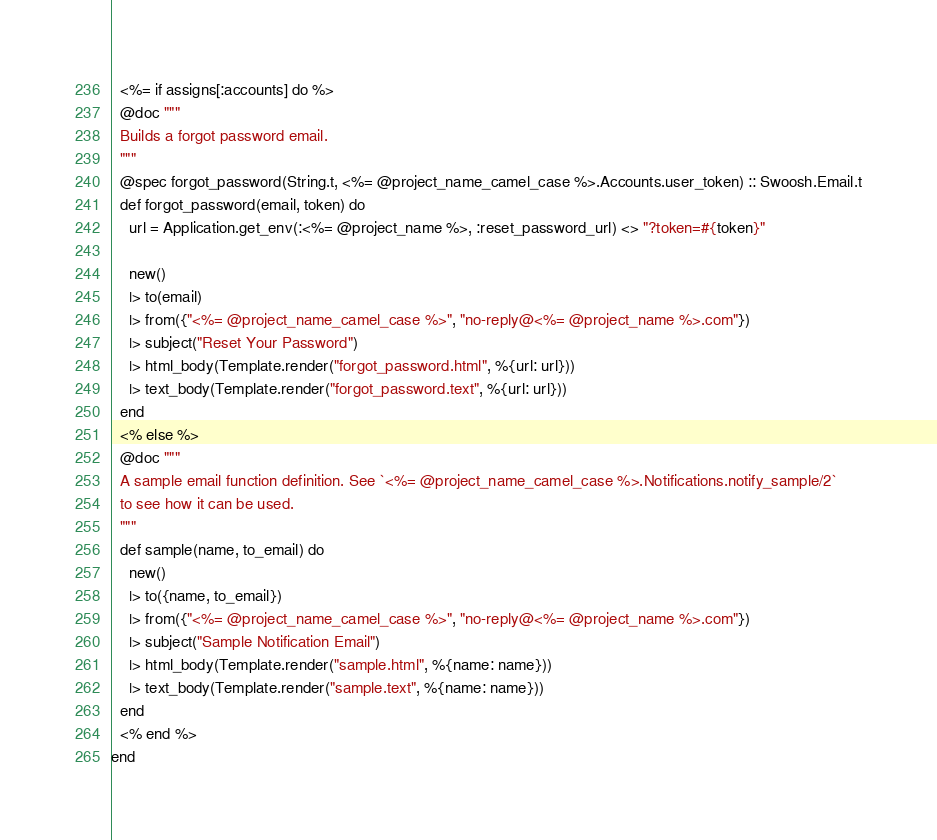Convert code to text. <code><loc_0><loc_0><loc_500><loc_500><_Elixir_>  <%= if assigns[:accounts] do %>
  @doc """
  Builds a forgot password email.
  """
  @spec forgot_password(String.t, <%= @project_name_camel_case %>.Accounts.user_token) :: Swoosh.Email.t
  def forgot_password(email, token) do
    url = Application.get_env(:<%= @project_name %>, :reset_password_url) <> "?token=#{token}"

    new()
    |> to(email)
    |> from({"<%= @project_name_camel_case %>", "no-reply@<%= @project_name %>.com"})
    |> subject("Reset Your Password")
    |> html_body(Template.render("forgot_password.html", %{url: url}))
    |> text_body(Template.render("forgot_password.text", %{url: url}))
  end
  <% else %>
  @doc """
  A sample email function definition. See `<%= @project_name_camel_case %>.Notifications.notify_sample/2`
  to see how it can be used.
  """
  def sample(name, to_email) do
    new()
    |> to({name, to_email})
    |> from({"<%= @project_name_camel_case %>", "no-reply@<%= @project_name %>.com"})
    |> subject("Sample Notification Email")
    |> html_body(Template.render("sample.html", %{name: name}))
    |> text_body(Template.render("sample.text", %{name: name}))
  end
  <% end %>
end</code> 